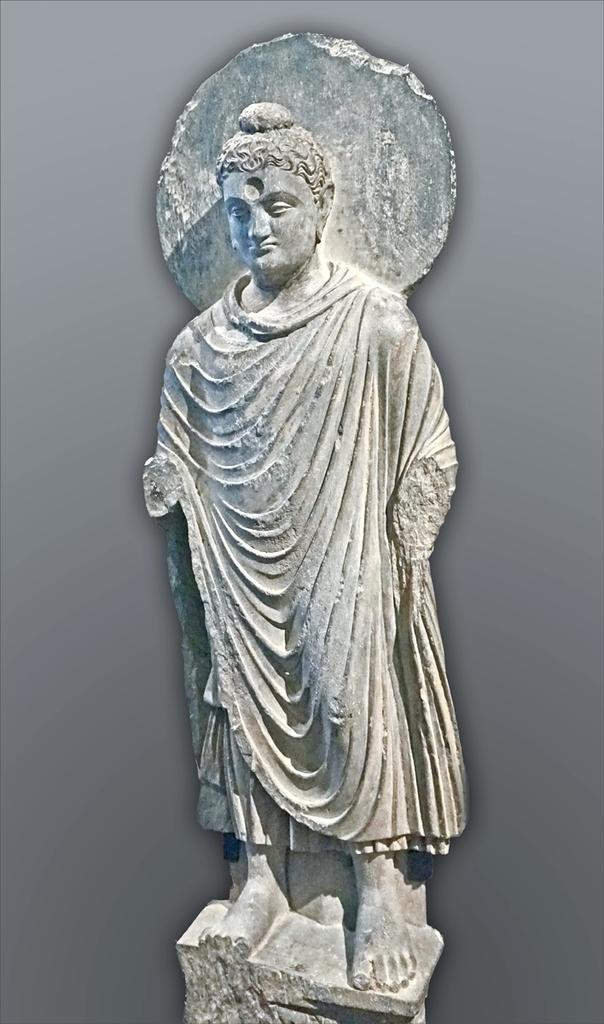Please provide a concise description of this image. Background portion of the picture is in gray color. In this picture we can see the statue placed on a pedestal. 